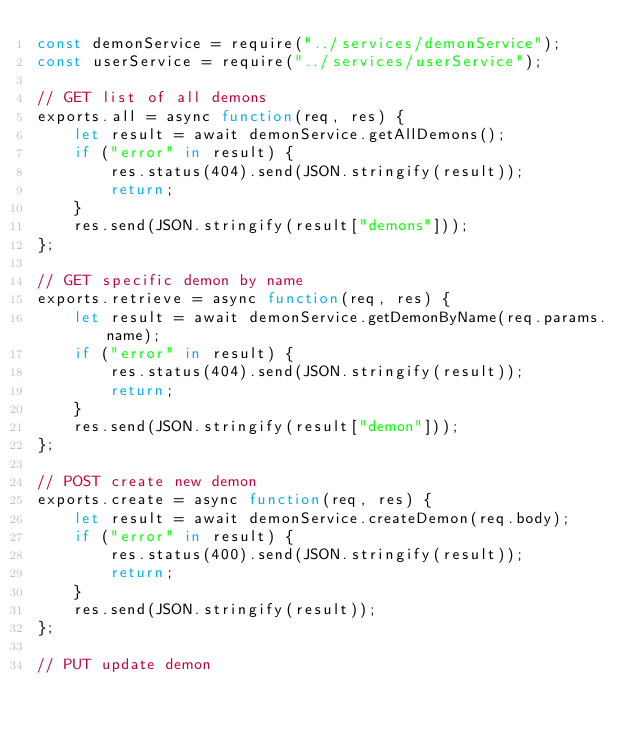<code> <loc_0><loc_0><loc_500><loc_500><_JavaScript_>const demonService = require("../services/demonService");
const userService = require("../services/userService");

// GET list of all demons
exports.all = async function(req, res) {
    let result = await demonService.getAllDemons();
    if ("error" in result) {
        res.status(404).send(JSON.stringify(result));
        return;
    }
    res.send(JSON.stringify(result["demons"]));
};

// GET specific demon by name
exports.retrieve = async function(req, res) {
    let result = await demonService.getDemonByName(req.params.name);
    if ("error" in result) {
        res.status(404).send(JSON.stringify(result));
        return;
    }
    res.send(JSON.stringify(result["demon"]));
};

// POST create new demon
exports.create = async function(req, res) {
    let result = await demonService.createDemon(req.body);
    if ("error" in result) {
        res.status(400).send(JSON.stringify(result));
        return;
    }
    res.send(JSON.stringify(result));
};

// PUT update demon</code> 